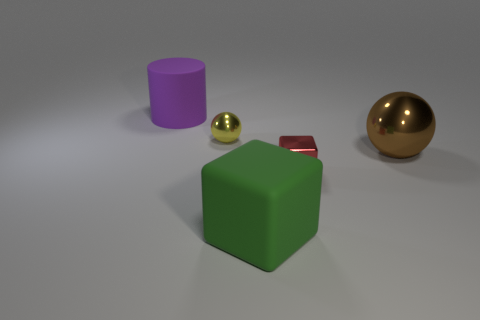There is a large matte thing behind the big brown metallic thing; are there any metal spheres in front of it?
Offer a very short reply. Yes. What number of small red metal things are behind the rubber object in front of the big rubber object that is behind the small cube?
Provide a short and direct response. 1. What is the color of the big thing that is behind the red thing and on the left side of the big sphere?
Your answer should be very brief. Purple. What number of metallic blocks have the same color as the cylinder?
Provide a succinct answer. 0. What number of cylinders are either tiny cyan things or large green rubber things?
Provide a succinct answer. 0. There is another object that is the same size as the yellow object; what color is it?
Your answer should be very brief. Red. There is a matte thing that is on the left side of the shiny ball that is left of the big block; is there a purple cylinder that is on the right side of it?
Provide a succinct answer. No. What size is the rubber cylinder?
Keep it short and to the point. Large. What number of objects are either green blocks or tiny yellow spheres?
Ensure brevity in your answer.  2. There is a cube that is the same material as the brown object; what is its color?
Keep it short and to the point. Red. 